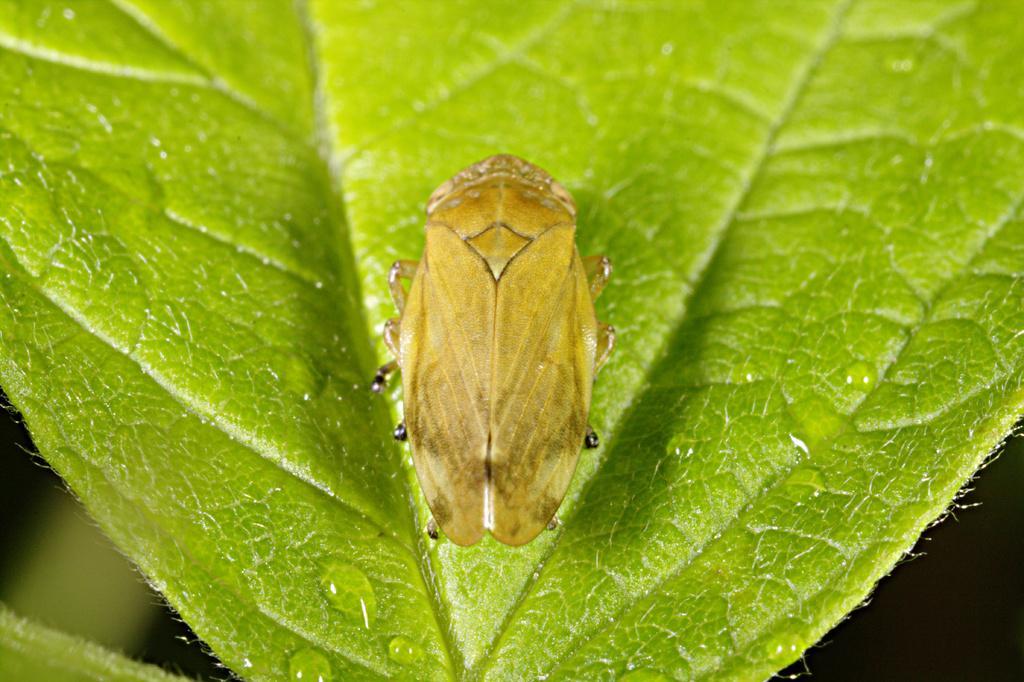Could you give a brief overview of what you see in this image? In this image I can see an insect on the leaf. I can see an insect is in brown color. And there is a blurred background. 